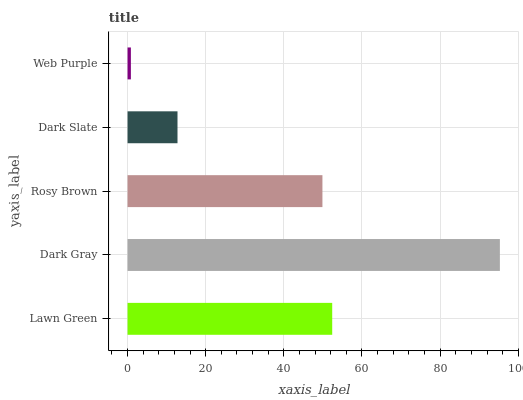Is Web Purple the minimum?
Answer yes or no. Yes. Is Dark Gray the maximum?
Answer yes or no. Yes. Is Rosy Brown the minimum?
Answer yes or no. No. Is Rosy Brown the maximum?
Answer yes or no. No. Is Dark Gray greater than Rosy Brown?
Answer yes or no. Yes. Is Rosy Brown less than Dark Gray?
Answer yes or no. Yes. Is Rosy Brown greater than Dark Gray?
Answer yes or no. No. Is Dark Gray less than Rosy Brown?
Answer yes or no. No. Is Rosy Brown the high median?
Answer yes or no. Yes. Is Rosy Brown the low median?
Answer yes or no. Yes. Is Dark Gray the high median?
Answer yes or no. No. Is Dark Slate the low median?
Answer yes or no. No. 